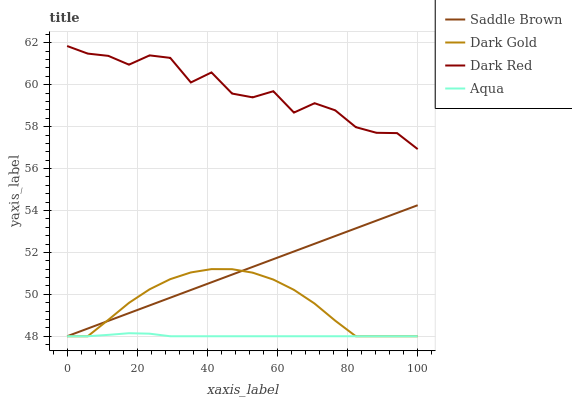Does Aqua have the minimum area under the curve?
Answer yes or no. Yes. Does Dark Red have the maximum area under the curve?
Answer yes or no. Yes. Does Saddle Brown have the minimum area under the curve?
Answer yes or no. No. Does Saddle Brown have the maximum area under the curve?
Answer yes or no. No. Is Saddle Brown the smoothest?
Answer yes or no. Yes. Is Dark Red the roughest?
Answer yes or no. Yes. Is Aqua the smoothest?
Answer yes or no. No. Is Aqua the roughest?
Answer yes or no. No. Does Aqua have the lowest value?
Answer yes or no. Yes. Does Dark Red have the highest value?
Answer yes or no. Yes. Does Saddle Brown have the highest value?
Answer yes or no. No. Is Aqua less than Dark Red?
Answer yes or no. Yes. Is Dark Red greater than Aqua?
Answer yes or no. Yes. Does Saddle Brown intersect Aqua?
Answer yes or no. Yes. Is Saddle Brown less than Aqua?
Answer yes or no. No. Is Saddle Brown greater than Aqua?
Answer yes or no. No. Does Aqua intersect Dark Red?
Answer yes or no. No. 